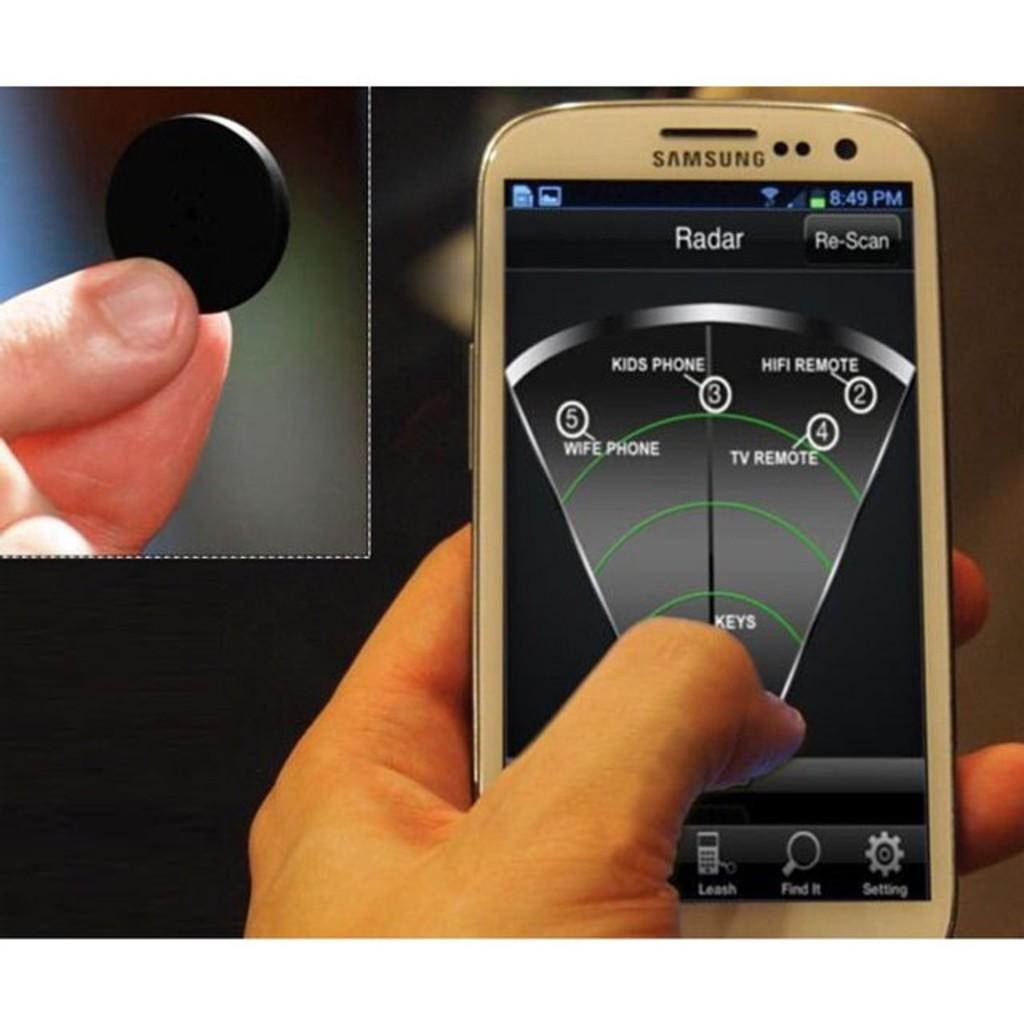<image>
Share a concise interpretation of the image provided. A person is using a white cell phone that says Samsung on the front. 